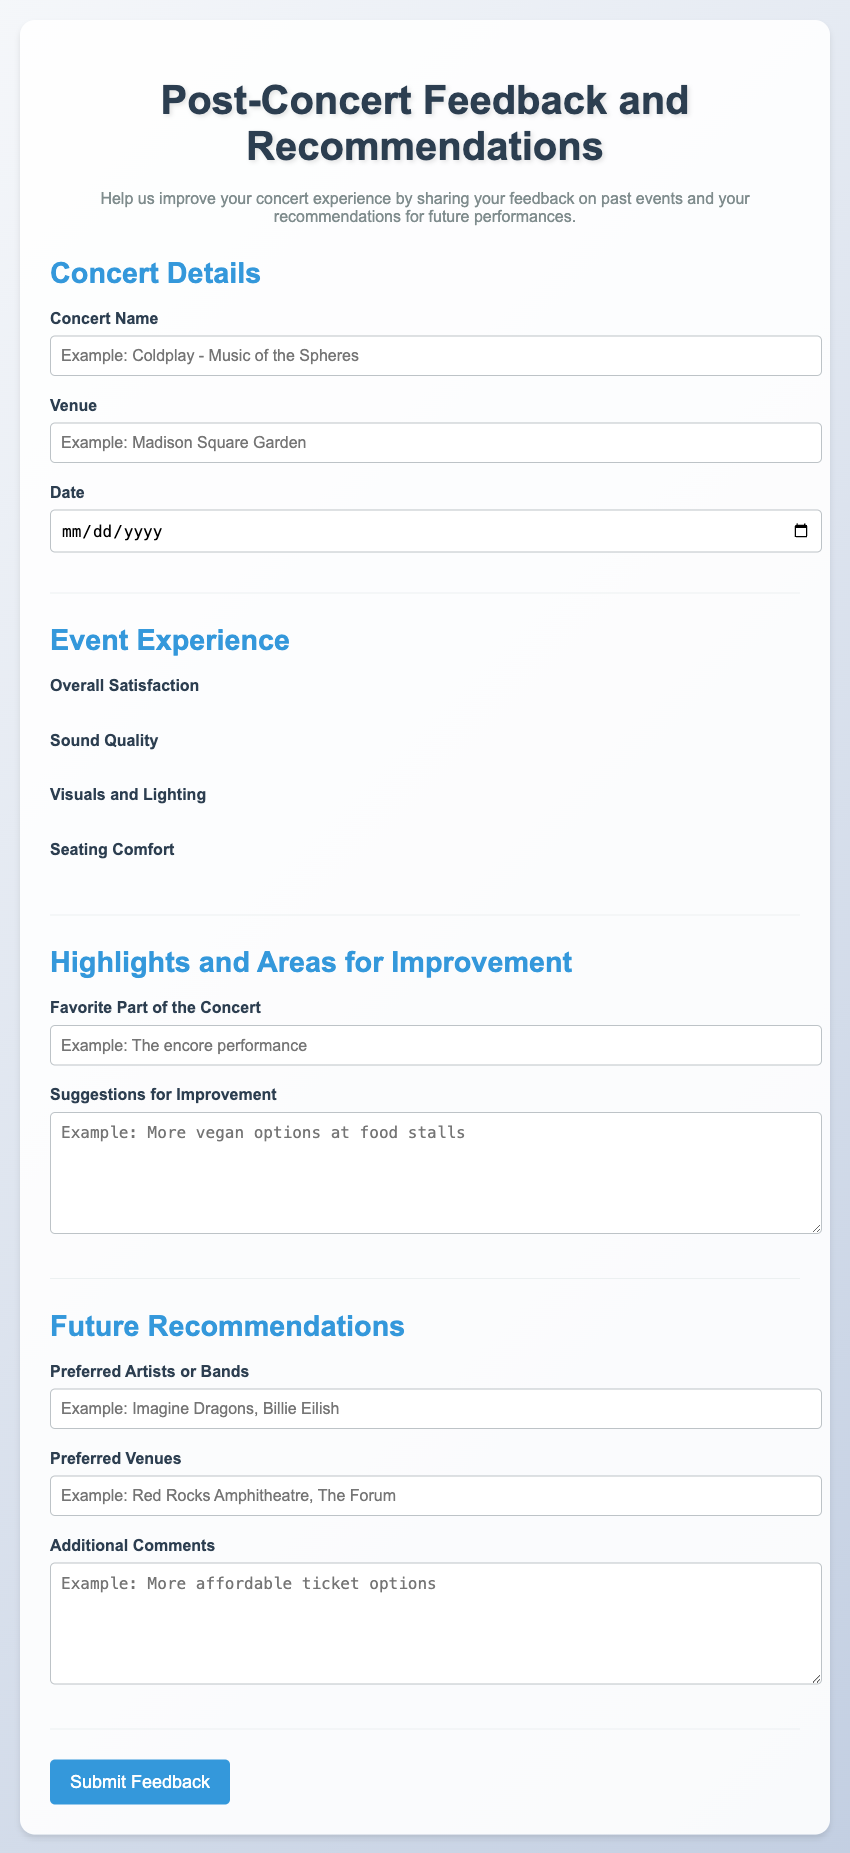What is the title of the document? The title appears in the <title> tag and matches the main heading of the document.
Answer: Post-Concert Feedback and Recommendations What is the main color theme of the document as seen in the background? The background features a gradient that transitions between two colors, as described in the CSS.
Answer: Light blue and light gray What day of the week is required for the date input? The date input requires a calendar date selection but does not specify a particular day of the week.
Answer: Any day What is asked for under 'Favorite Part of the Concert'? This input field prompts for a specific aspect that the attendee enjoyed the most.
Answer: Favorite Part of the Concert What type of input is used for 'Overall Satisfaction'? This section uses a specific method for rating, as shown by the structured format of the components in that section.
Answer: Rating scale (stars) What is one suggestion provided for improvement in the survey? The document includes a field for attendees to provide insights on how the concert experience could be enhanced.
Answer: Suggestions for Improvement How many sections are there in the form? The document is structured into distinct parts that encapsulate various feedback areas.
Answer: Four sections What kind of input does the 'Preferred Artists or Bands' field require? This field is designed for textual input, where attendees can list their favorite musicians.
Answer: Text input What will happen when the 'Submit Feedback' button is clicked? This button is supposed to submit the responses entered in the survey form.
Answer: Submit feedback 